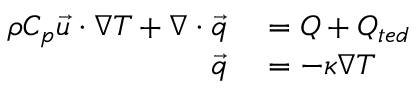Convert formula to latex. <formula><loc_0><loc_0><loc_500><loc_500>\begin{array} { r l } { \rho C _ { p } \ V e c { u } \cdot \nabla T + \nabla \cdot \ V e c { q } } & = Q + Q _ { t e d } } \\ { \ V e c { q } } & = - \kappa \nabla T } \end{array}</formula> 